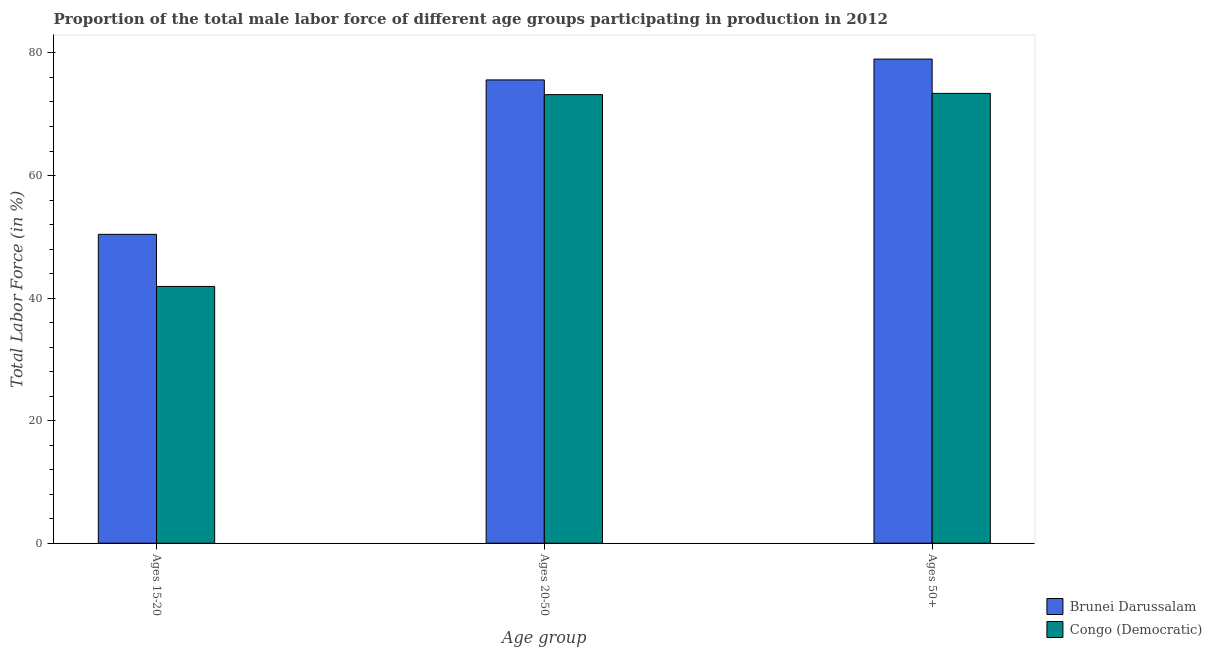How many different coloured bars are there?
Your answer should be compact. 2. How many groups of bars are there?
Ensure brevity in your answer.  3. Are the number of bars per tick equal to the number of legend labels?
Your answer should be very brief. Yes. Are the number of bars on each tick of the X-axis equal?
Give a very brief answer. Yes. How many bars are there on the 3rd tick from the right?
Give a very brief answer. 2. What is the label of the 1st group of bars from the left?
Provide a short and direct response. Ages 15-20. What is the percentage of male labor force within the age group 20-50 in Brunei Darussalam?
Ensure brevity in your answer.  75.6. Across all countries, what is the maximum percentage of male labor force within the age group 20-50?
Provide a succinct answer. 75.6. Across all countries, what is the minimum percentage of male labor force within the age group 15-20?
Your response must be concise. 41.9. In which country was the percentage of male labor force above age 50 maximum?
Offer a very short reply. Brunei Darussalam. In which country was the percentage of male labor force within the age group 20-50 minimum?
Make the answer very short. Congo (Democratic). What is the total percentage of male labor force within the age group 15-20 in the graph?
Ensure brevity in your answer.  92.3. What is the difference between the percentage of male labor force within the age group 15-20 in Brunei Darussalam and the percentage of male labor force above age 50 in Congo (Democratic)?
Keep it short and to the point. -23. What is the average percentage of male labor force within the age group 15-20 per country?
Provide a short and direct response. 46.15. What is the difference between the percentage of male labor force within the age group 20-50 and percentage of male labor force above age 50 in Brunei Darussalam?
Give a very brief answer. -3.4. What is the ratio of the percentage of male labor force within the age group 15-20 in Brunei Darussalam to that in Congo (Democratic)?
Offer a very short reply. 1.2. Is the percentage of male labor force within the age group 15-20 in Congo (Democratic) less than that in Brunei Darussalam?
Your answer should be compact. Yes. Is the difference between the percentage of male labor force above age 50 in Congo (Democratic) and Brunei Darussalam greater than the difference between the percentage of male labor force within the age group 15-20 in Congo (Democratic) and Brunei Darussalam?
Keep it short and to the point. Yes. What is the difference between the highest and the second highest percentage of male labor force within the age group 15-20?
Your response must be concise. 8.5. What is the difference between the highest and the lowest percentage of male labor force above age 50?
Offer a terse response. 5.6. What does the 2nd bar from the left in Ages 20-50 represents?
Keep it short and to the point. Congo (Democratic). What does the 2nd bar from the right in Ages 15-20 represents?
Provide a short and direct response. Brunei Darussalam. Is it the case that in every country, the sum of the percentage of male labor force within the age group 15-20 and percentage of male labor force within the age group 20-50 is greater than the percentage of male labor force above age 50?
Provide a succinct answer. Yes. How many bars are there?
Ensure brevity in your answer.  6. Are all the bars in the graph horizontal?
Provide a short and direct response. No. How many countries are there in the graph?
Your answer should be very brief. 2. Are the values on the major ticks of Y-axis written in scientific E-notation?
Offer a terse response. No. Does the graph contain any zero values?
Make the answer very short. No. Does the graph contain grids?
Provide a short and direct response. No. Where does the legend appear in the graph?
Your response must be concise. Bottom right. How are the legend labels stacked?
Offer a terse response. Vertical. What is the title of the graph?
Your answer should be very brief. Proportion of the total male labor force of different age groups participating in production in 2012. Does "Kyrgyz Republic" appear as one of the legend labels in the graph?
Provide a succinct answer. No. What is the label or title of the X-axis?
Your answer should be very brief. Age group. What is the label or title of the Y-axis?
Offer a terse response. Total Labor Force (in %). What is the Total Labor Force (in %) of Brunei Darussalam in Ages 15-20?
Offer a terse response. 50.4. What is the Total Labor Force (in %) of Congo (Democratic) in Ages 15-20?
Ensure brevity in your answer.  41.9. What is the Total Labor Force (in %) in Brunei Darussalam in Ages 20-50?
Provide a short and direct response. 75.6. What is the Total Labor Force (in %) in Congo (Democratic) in Ages 20-50?
Offer a very short reply. 73.2. What is the Total Labor Force (in %) in Brunei Darussalam in Ages 50+?
Keep it short and to the point. 79. What is the Total Labor Force (in %) in Congo (Democratic) in Ages 50+?
Make the answer very short. 73.4. Across all Age group, what is the maximum Total Labor Force (in %) of Brunei Darussalam?
Your answer should be compact. 79. Across all Age group, what is the maximum Total Labor Force (in %) in Congo (Democratic)?
Your answer should be very brief. 73.4. Across all Age group, what is the minimum Total Labor Force (in %) in Brunei Darussalam?
Your answer should be very brief. 50.4. Across all Age group, what is the minimum Total Labor Force (in %) of Congo (Democratic)?
Provide a short and direct response. 41.9. What is the total Total Labor Force (in %) of Brunei Darussalam in the graph?
Your answer should be compact. 205. What is the total Total Labor Force (in %) in Congo (Democratic) in the graph?
Offer a terse response. 188.5. What is the difference between the Total Labor Force (in %) in Brunei Darussalam in Ages 15-20 and that in Ages 20-50?
Provide a short and direct response. -25.2. What is the difference between the Total Labor Force (in %) of Congo (Democratic) in Ages 15-20 and that in Ages 20-50?
Provide a succinct answer. -31.3. What is the difference between the Total Labor Force (in %) of Brunei Darussalam in Ages 15-20 and that in Ages 50+?
Your answer should be compact. -28.6. What is the difference between the Total Labor Force (in %) of Congo (Democratic) in Ages 15-20 and that in Ages 50+?
Your answer should be compact. -31.5. What is the difference between the Total Labor Force (in %) in Brunei Darussalam in Ages 15-20 and the Total Labor Force (in %) in Congo (Democratic) in Ages 20-50?
Your response must be concise. -22.8. What is the difference between the Total Labor Force (in %) of Brunei Darussalam in Ages 15-20 and the Total Labor Force (in %) of Congo (Democratic) in Ages 50+?
Provide a short and direct response. -23. What is the average Total Labor Force (in %) of Brunei Darussalam per Age group?
Your answer should be very brief. 68.33. What is the average Total Labor Force (in %) in Congo (Democratic) per Age group?
Your answer should be very brief. 62.83. What is the difference between the Total Labor Force (in %) of Brunei Darussalam and Total Labor Force (in %) of Congo (Democratic) in Ages 15-20?
Offer a very short reply. 8.5. What is the ratio of the Total Labor Force (in %) in Congo (Democratic) in Ages 15-20 to that in Ages 20-50?
Provide a succinct answer. 0.57. What is the ratio of the Total Labor Force (in %) of Brunei Darussalam in Ages 15-20 to that in Ages 50+?
Give a very brief answer. 0.64. What is the ratio of the Total Labor Force (in %) in Congo (Democratic) in Ages 15-20 to that in Ages 50+?
Keep it short and to the point. 0.57. What is the ratio of the Total Labor Force (in %) of Brunei Darussalam in Ages 20-50 to that in Ages 50+?
Your answer should be compact. 0.96. What is the difference between the highest and the second highest Total Labor Force (in %) of Brunei Darussalam?
Provide a short and direct response. 3.4. What is the difference between the highest and the second highest Total Labor Force (in %) in Congo (Democratic)?
Ensure brevity in your answer.  0.2. What is the difference between the highest and the lowest Total Labor Force (in %) of Brunei Darussalam?
Your response must be concise. 28.6. What is the difference between the highest and the lowest Total Labor Force (in %) of Congo (Democratic)?
Keep it short and to the point. 31.5. 